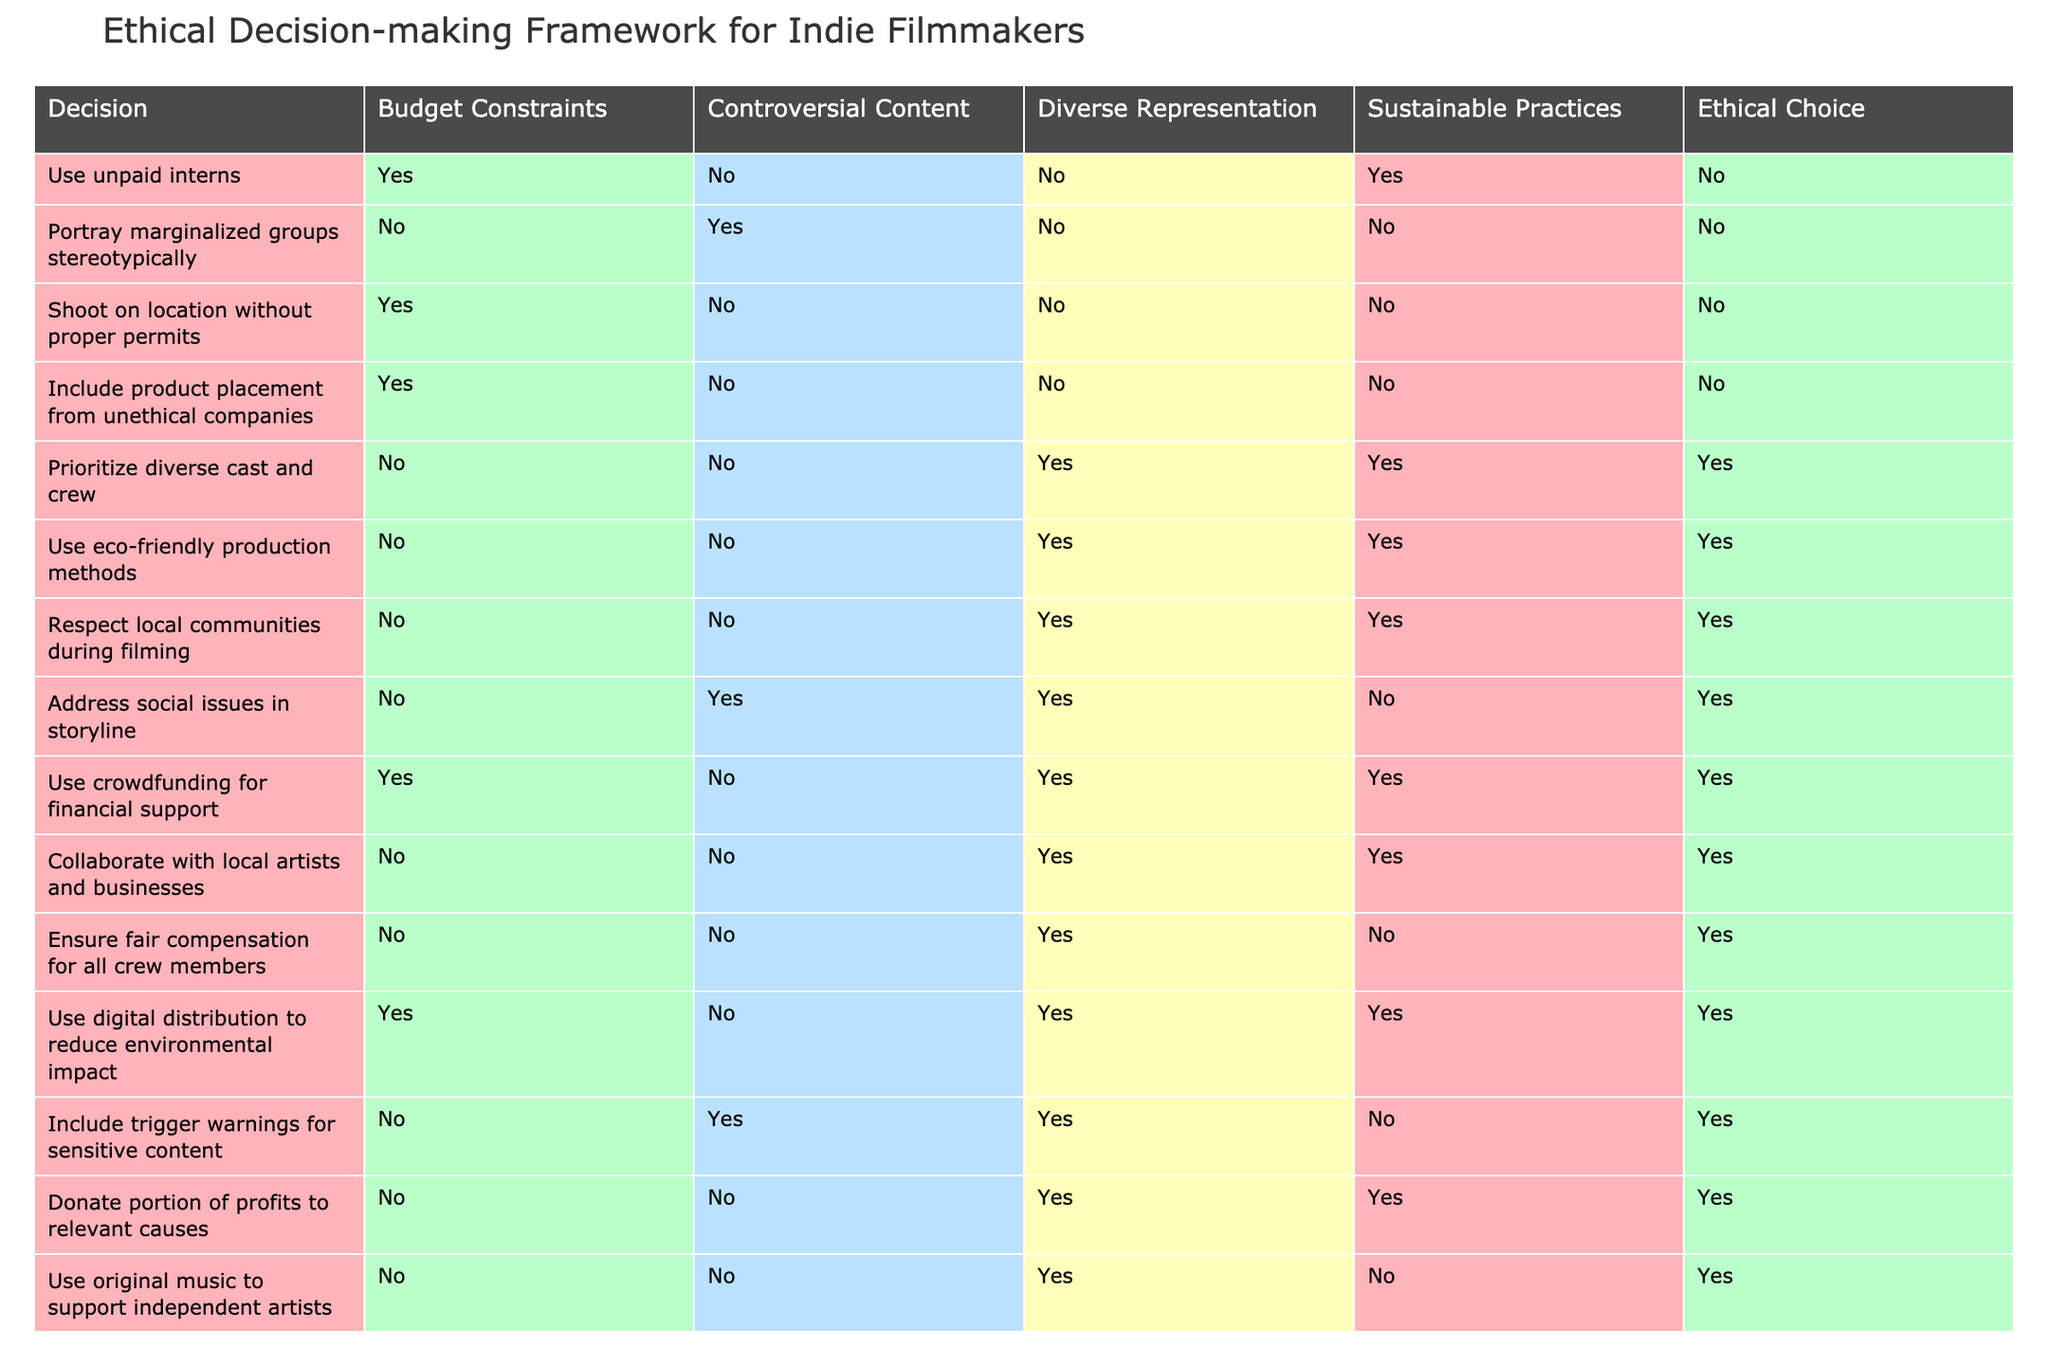What ethical choice is associated with including trigger warnings for sensitive content? The table shows that including trigger warnings for sensitive content has an ethical choice of 'Yes.' It can be found by locating the row for this particular decision and checking the corresponding 'Ethical Choice' column.
Answer: Yes Is it ethical to shoot on location without proper permits? According to the data, shooting on location without proper permits is associated with the ethical choice of 'No.' This is directly taken from the specific row that outlines this decision.
Answer: No How many ethical decisions include sustainability practices? To find the answer, we can count the number of rows where 'Sustainable Practices' is 'Yes.' By examining the table, we find that there are 5 decisions that meet this criterion.
Answer: 5 What proportion of decisions that prioritize diverse representation also ensure fair compensation for all crew members? We look for the two relevant decisions. "Prioritize diverse cast and crew" has an ethical choice of 'Yes,' and "Ensure fair compensation for all crew members" also has 'Yes.' Both are in the table, resulting in a proportion of 1 out of 2, or 50%.
Answer: 50% Which decisions are ethical if crowdfunding for financial support is used? We check the row for 'Use crowdfunding for financial support,' which indicates that this decision is ethical. It shows that 'Prioritize diverse cast and crew,' 'Use eco-friendly production methods,' 'Respect local communities during filming,' 'Donate portion of profits to relevant causes,' and 'Collaborate with local artists and businesses' are ethical choices when combined with crowdfunding. Therefore, these five decisions are ethical when crowdfunding is involved.
Answer: 5 decisions Are there any decisions that allow for controversial content but still result in ethical choices? By examining the table, we note that the decision 'Portray marginalized groups stereotypically' results in 'No' for ethical choices. There are no other decisions that allow for controversial content while achieving an ethical choice, meaning the answer is no.
Answer: No If an indie film decision incorporates eco-friendly production methods, what is the maximum number of ethical decisions possible? We look at the row for 'Use eco-friendly production methods,' which is associated with an ethical choice of 'Yes.' By reviewing the table, this particular decision allows for the most ethical choices, which also include 'Prioritize diverse cast and crew,' 'Respect local communities during filming,' and 'Donate portion of profits to relevant causes,' giving a total of 5 ethical decisions that arise from incorporating eco-friendly practices.
Answer: 5 decisions Is it ethical to use unpaid interns if sustainability practices are prioritized? Checking the rows reveals that 'Use unpaid interns' results in 'No' for an ethical choice, while 'Sustainable Practices' aligns with several ethical decisions, which means the two cannot coexist. Thus, the combination does not yield an ethical choice.
Answer: No What is the total number of decisions that do not respect local communities during filming? To determine this, we count the number of rows where 'Respect local communities during filming' is 'No.' This results in a total of 6 decisions that do not respect local communities.
Answer: 6 